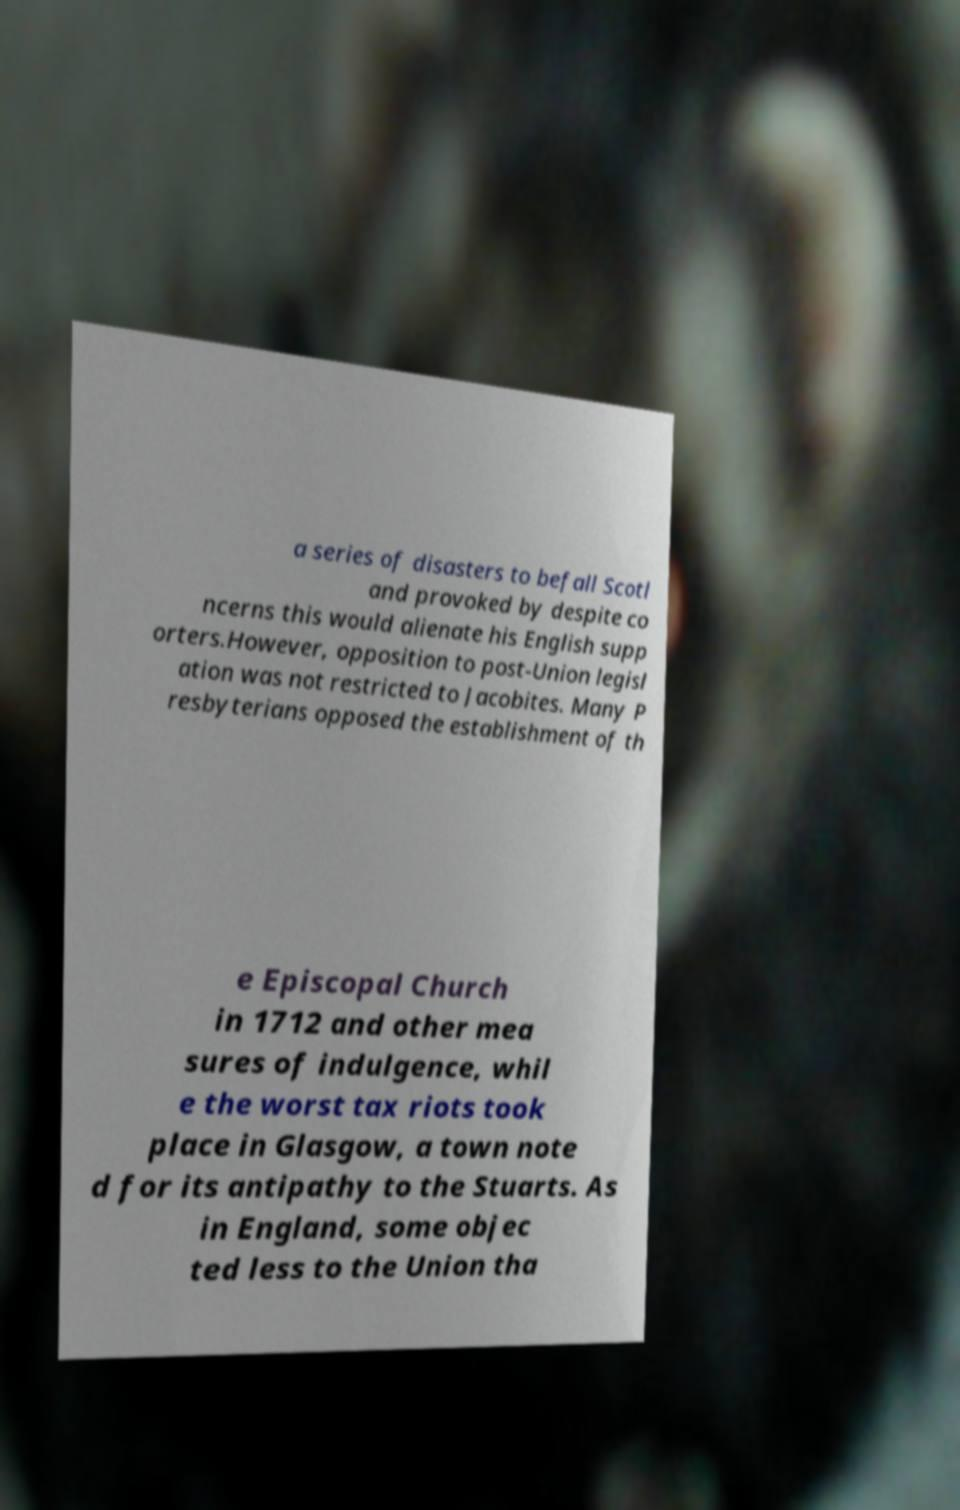There's text embedded in this image that I need extracted. Can you transcribe it verbatim? a series of disasters to befall Scotl and provoked by despite co ncerns this would alienate his English supp orters.However, opposition to post-Union legisl ation was not restricted to Jacobites. Many P resbyterians opposed the establishment of th e Episcopal Church in 1712 and other mea sures of indulgence, whil e the worst tax riots took place in Glasgow, a town note d for its antipathy to the Stuarts. As in England, some objec ted less to the Union tha 